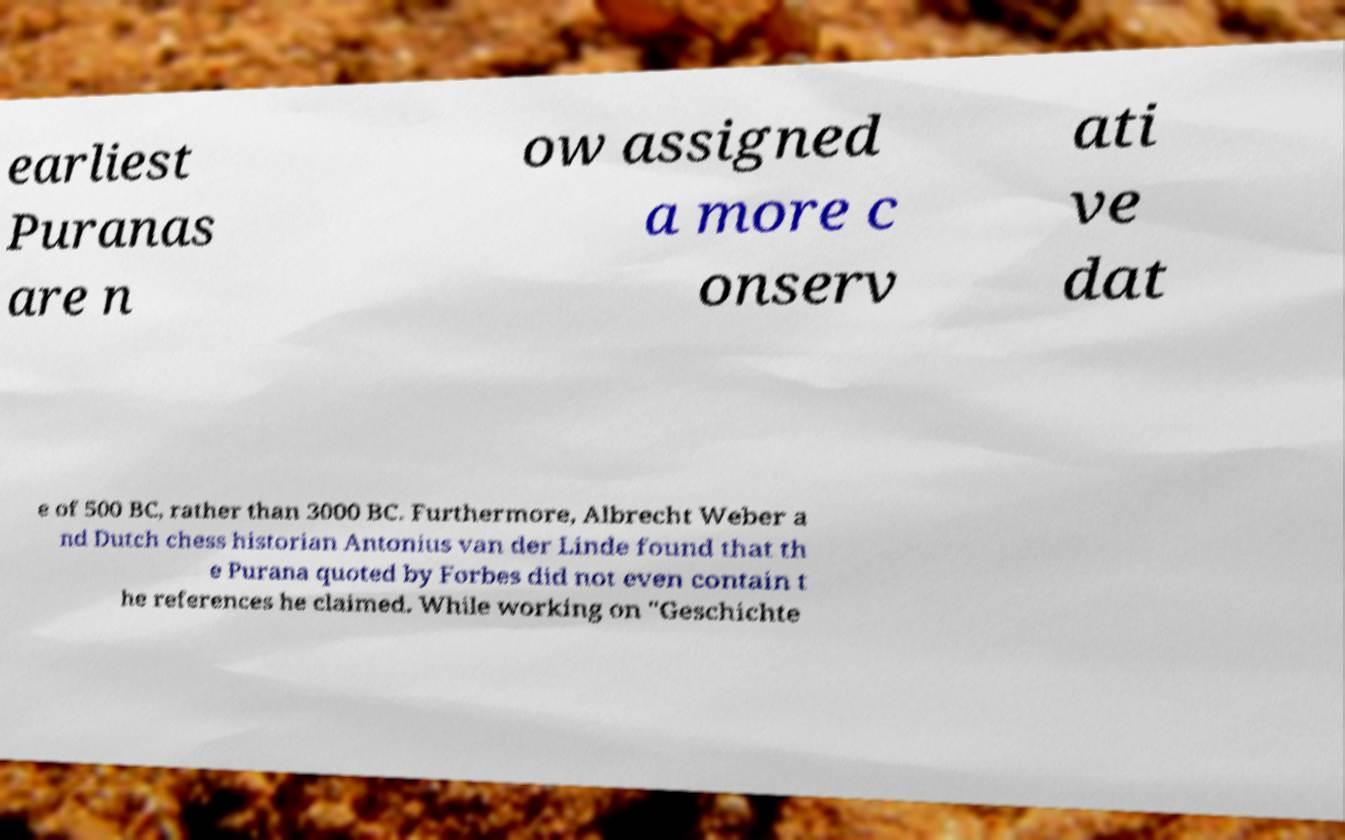Could you assist in decoding the text presented in this image and type it out clearly? earliest Puranas are n ow assigned a more c onserv ati ve dat e of 500 BC, rather than 3000 BC. Furthermore, Albrecht Weber a nd Dutch chess historian Antonius van der Linde found that th e Purana quoted by Forbes did not even contain t he references he claimed. While working on "Geschichte 